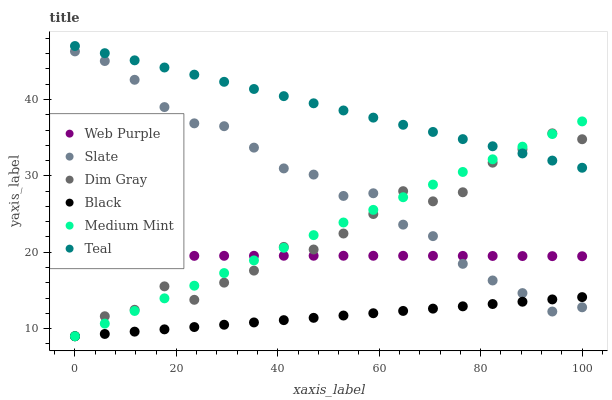Does Black have the minimum area under the curve?
Answer yes or no. Yes. Does Teal have the maximum area under the curve?
Answer yes or no. Yes. Does Dim Gray have the minimum area under the curve?
Answer yes or no. No. Does Dim Gray have the maximum area under the curve?
Answer yes or no. No. Is Black the smoothest?
Answer yes or no. Yes. Is Dim Gray the roughest?
Answer yes or no. Yes. Is Slate the smoothest?
Answer yes or no. No. Is Slate the roughest?
Answer yes or no. No. Does Medium Mint have the lowest value?
Answer yes or no. Yes. Does Slate have the lowest value?
Answer yes or no. No. Does Teal have the highest value?
Answer yes or no. Yes. Does Dim Gray have the highest value?
Answer yes or no. No. Is Black less than Teal?
Answer yes or no. Yes. Is Teal greater than Web Purple?
Answer yes or no. Yes. Does Teal intersect Dim Gray?
Answer yes or no. Yes. Is Teal less than Dim Gray?
Answer yes or no. No. Is Teal greater than Dim Gray?
Answer yes or no. No. Does Black intersect Teal?
Answer yes or no. No. 